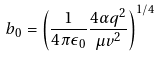Convert formula to latex. <formula><loc_0><loc_0><loc_500><loc_500>b _ { 0 } = \left ( \frac { 1 } { 4 \pi \epsilon _ { 0 } } \frac { 4 \alpha q ^ { 2 } } { \mu v ^ { 2 } } \right ) ^ { 1 / 4 }</formula> 